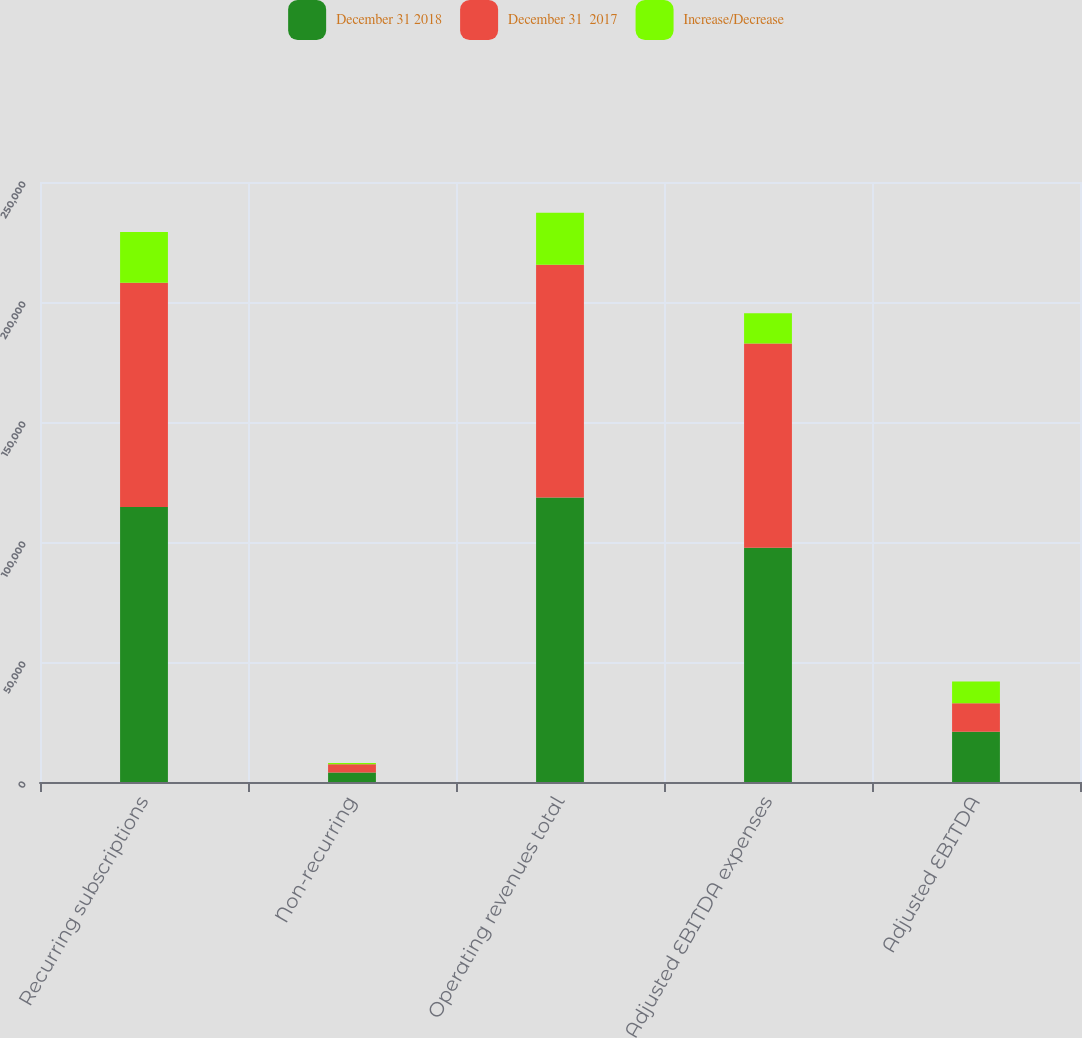Convert chart to OTSL. <chart><loc_0><loc_0><loc_500><loc_500><stacked_bar_chart><ecel><fcel>Recurring subscriptions<fcel>Non-recurring<fcel>Operating revenues total<fcel>Adjusted EBITDA expenses<fcel>Adjusted EBITDA<nl><fcel>December 31 2018<fcel>114590<fcel>3980<fcel>118570<fcel>97635<fcel>20935<nl><fcel>December 31  2017<fcel>93481<fcel>3463<fcel>96944<fcel>85052<fcel>11892<nl><fcel>Increase/Decrease<fcel>21109<fcel>517<fcel>21626<fcel>12583<fcel>9043<nl></chart> 